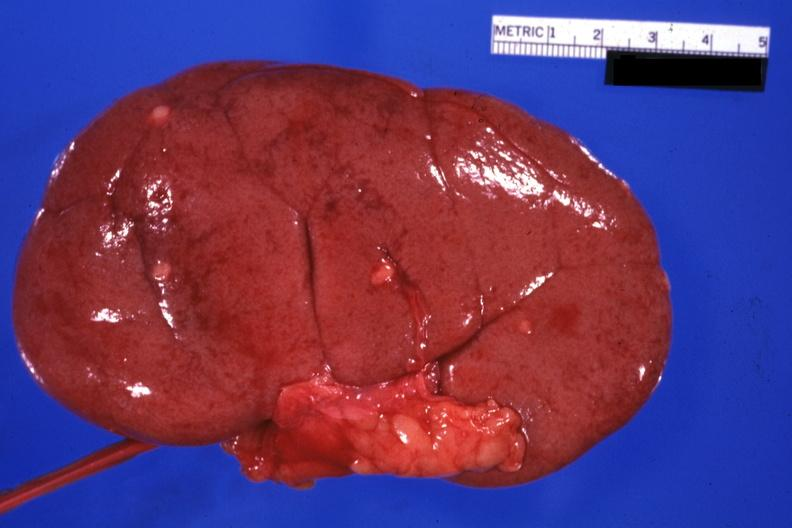what does this image show?
Answer the question using a single word or phrase. External view with capsule removed small lesions easily seen 